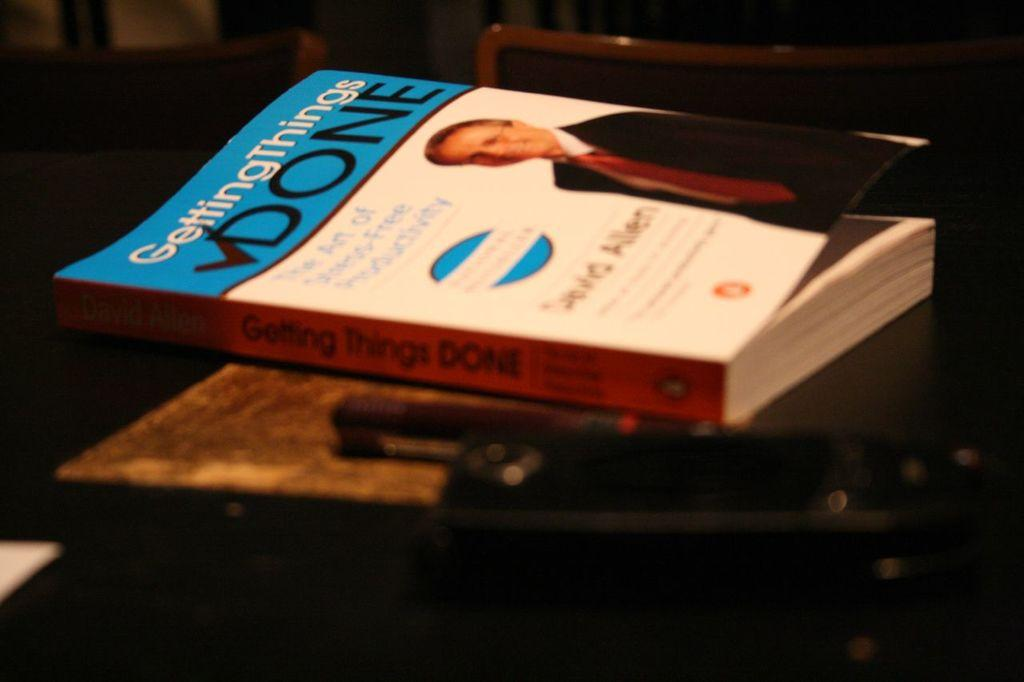<image>
Describe the image concisely. An orange, blue and white non-fiction book is entitled Getting Things Done. 